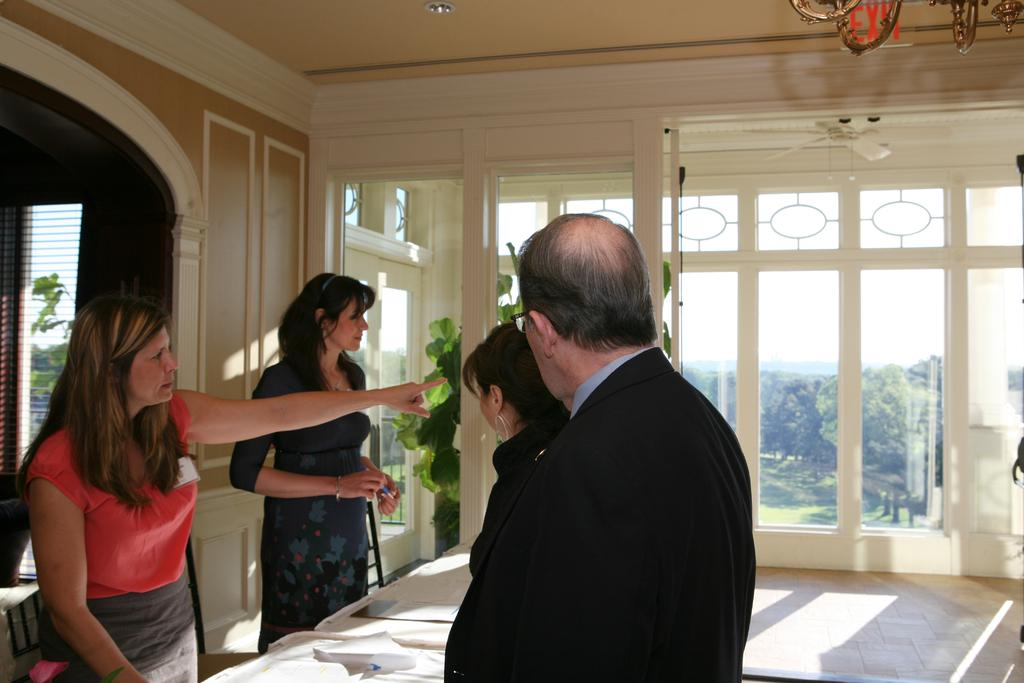How many people are present in the image? There are three women and a man in the image, making a total of four people. What is located in the middle of the image? There is a table in the middle of the image. What can be seen through the glass door in the background? Trees and the sky are visible through the glass door. What type of fear is the governor experiencing in the image? There is no governor present in the image, and therefore no fear can be attributed to a governor. 